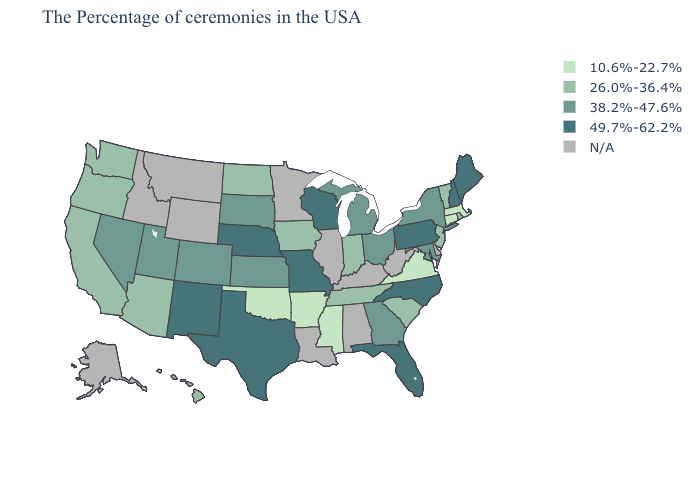Which states have the lowest value in the Northeast?
Answer briefly. Massachusetts, Connecticut. Does Michigan have the lowest value in the MidWest?
Answer briefly. No. Which states have the lowest value in the South?
Answer briefly. Virginia, Mississippi, Arkansas, Oklahoma. What is the value of California?
Quick response, please. 26.0%-36.4%. What is the lowest value in the USA?
Be succinct. 10.6%-22.7%. Name the states that have a value in the range 26.0%-36.4%?
Give a very brief answer. Rhode Island, Vermont, New Jersey, South Carolina, Indiana, Tennessee, Iowa, North Dakota, Arizona, California, Washington, Oregon, Hawaii. What is the lowest value in states that border Idaho?
Answer briefly. 26.0%-36.4%. Which states have the lowest value in the USA?
Concise answer only. Massachusetts, Connecticut, Virginia, Mississippi, Arkansas, Oklahoma. Among the states that border Tennessee , which have the highest value?
Short answer required. North Carolina, Missouri. Does North Dakota have the lowest value in the USA?
Give a very brief answer. No. Name the states that have a value in the range 10.6%-22.7%?
Quick response, please. Massachusetts, Connecticut, Virginia, Mississippi, Arkansas, Oklahoma. Among the states that border New Jersey , which have the lowest value?
Keep it brief. New York. 